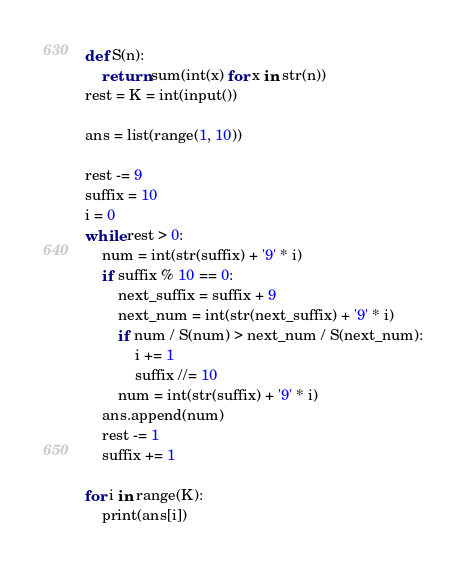<code> <loc_0><loc_0><loc_500><loc_500><_Python_>def S(n):
    return sum(int(x) for x in str(n))
rest = K = int(input())

ans = list(range(1, 10))

rest -= 9
suffix = 10
i = 0
while rest > 0:
    num = int(str(suffix) + '9' * i)
    if suffix % 10 == 0:
        next_suffix = suffix + 9
        next_num = int(str(next_suffix) + '9' * i)
        if num / S(num) > next_num / S(next_num):
            i += 1
            suffix //= 10
        num = int(str(suffix) + '9' * i)
    ans.append(num)
    rest -= 1
    suffix += 1

for i in range(K):
    print(ans[i])
</code> 